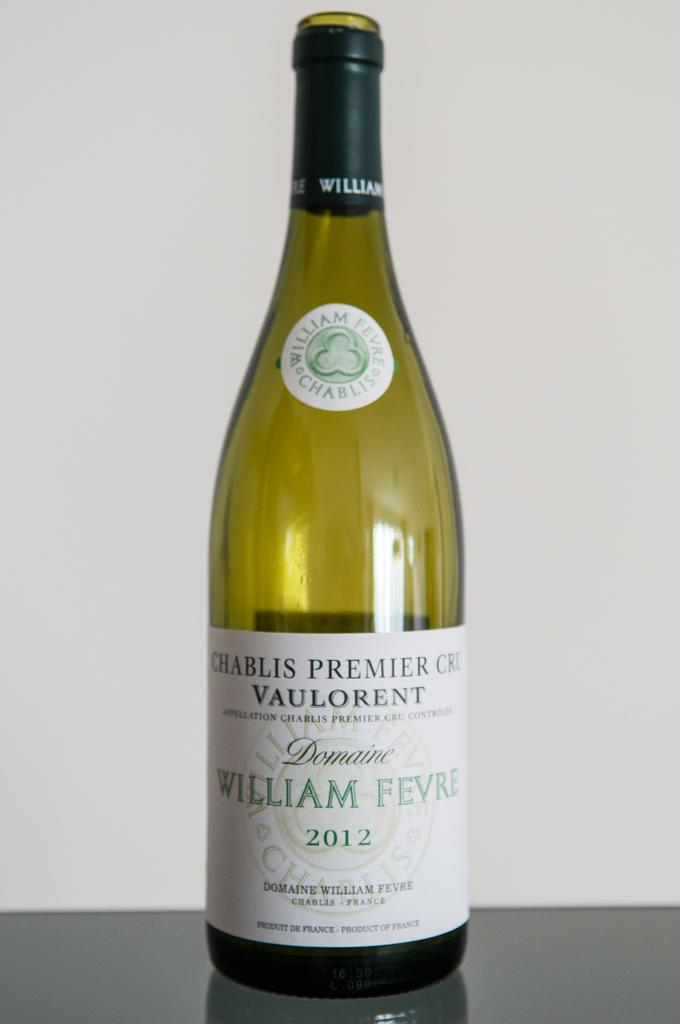<image>
Relay a brief, clear account of the picture shown. An empty bottle, with no cork, of William Fevre Chablis is on display. 